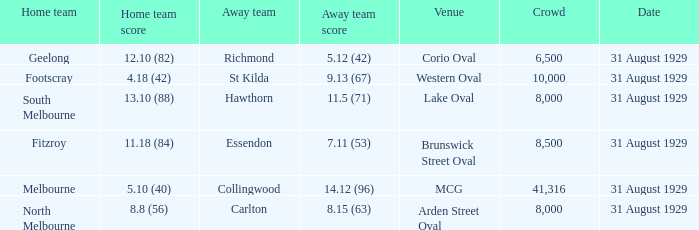12 (96)? 5.10 (40). Would you be able to parse every entry in this table? {'header': ['Home team', 'Home team score', 'Away team', 'Away team score', 'Venue', 'Crowd', 'Date'], 'rows': [['Geelong', '12.10 (82)', 'Richmond', '5.12 (42)', 'Corio Oval', '6,500', '31 August 1929'], ['Footscray', '4.18 (42)', 'St Kilda', '9.13 (67)', 'Western Oval', '10,000', '31 August 1929'], ['South Melbourne', '13.10 (88)', 'Hawthorn', '11.5 (71)', 'Lake Oval', '8,000', '31 August 1929'], ['Fitzroy', '11.18 (84)', 'Essendon', '7.11 (53)', 'Brunswick Street Oval', '8,500', '31 August 1929'], ['Melbourne', '5.10 (40)', 'Collingwood', '14.12 (96)', 'MCG', '41,316', '31 August 1929'], ['North Melbourne', '8.8 (56)', 'Carlton', '8.15 (63)', 'Arden Street Oval', '8,000', '31 August 1929']]} 